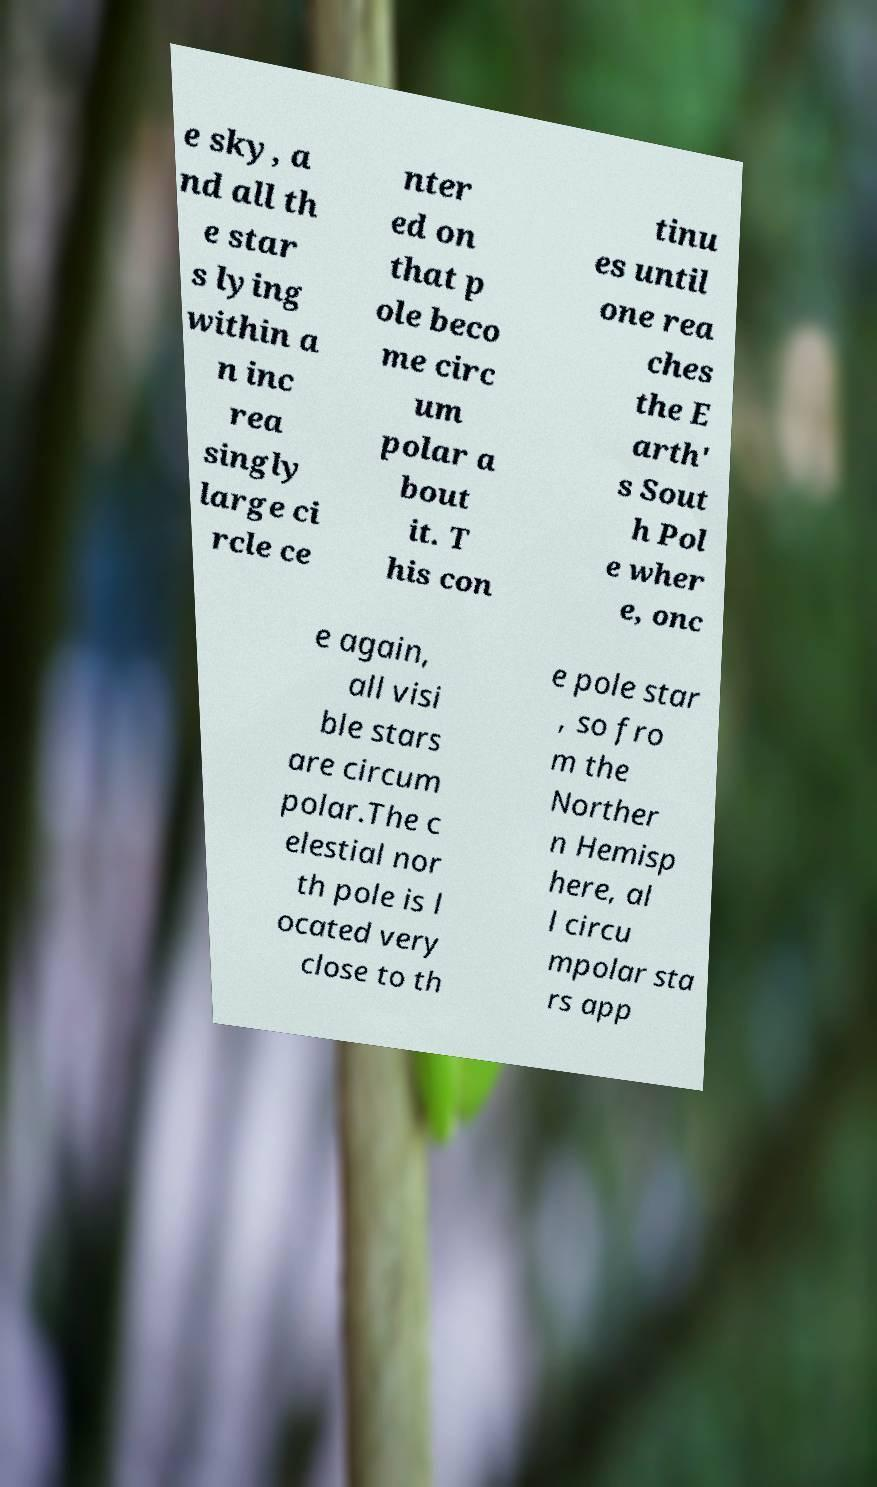Please identify and transcribe the text found in this image. e sky, a nd all th e star s lying within a n inc rea singly large ci rcle ce nter ed on that p ole beco me circ um polar a bout it. T his con tinu es until one rea ches the E arth' s Sout h Pol e wher e, onc e again, all visi ble stars are circum polar.The c elestial nor th pole is l ocated very close to th e pole star , so fro m the Norther n Hemisp here, al l circu mpolar sta rs app 